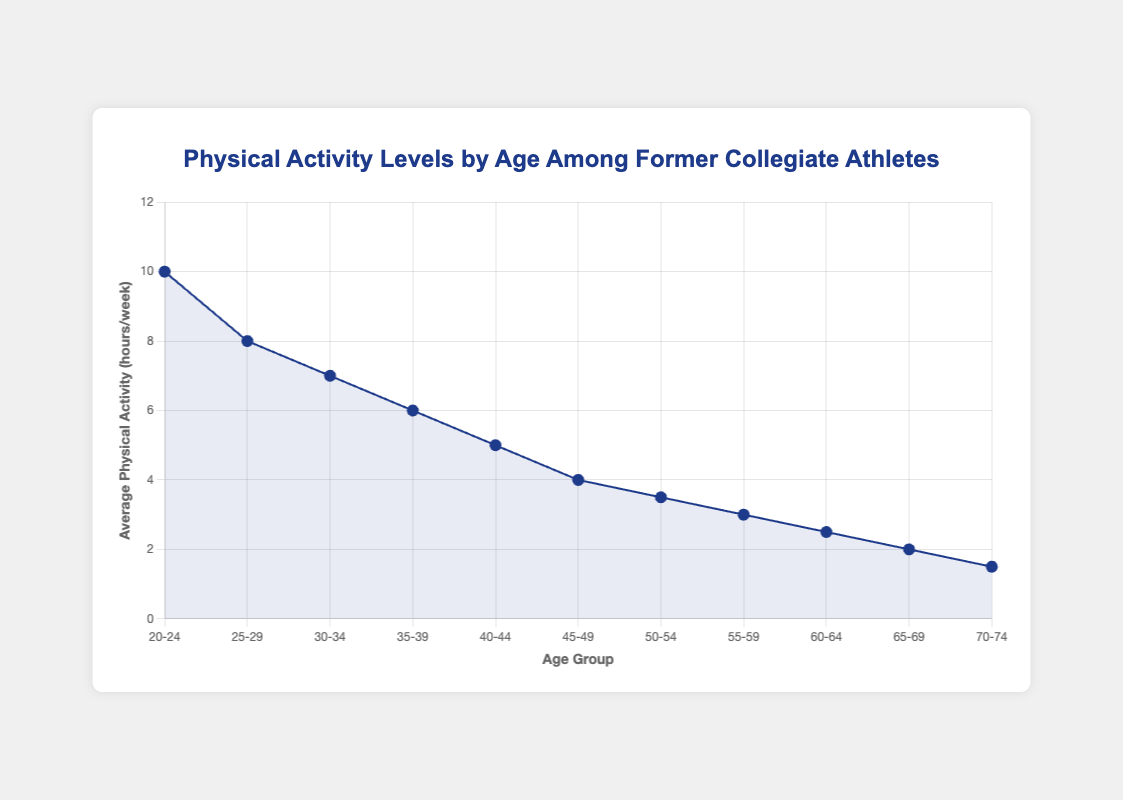What's the average number of physical activity hours per week for the 30-34 and 35-39 age groups combined? Add the average physical activity hours per week for the 30-34 (7 hours) and 35-39 (6 hours) age groups: 7 + 6 = 13. Then, divide by 2 to get the average: 13 / 2 = 6.5
Answer: 6.5 Which age group has the highest average physical activity hours per week? Looking at the figure, the age group with the highest point on the Y-axis is 20-24, which has 10 hours per week
Answer: 20-24 How does the decline in physical activity hours from the 20-24 age group to the 40-44 age group compare? The 20-24 age group has 10 hours per week and the 40-44 age group has 5 hours per week. The decline is: 10 - 5 = 5 hours
Answer: 5 hours Compare the difference in physical activity hours per week between the 25-29 and 50-54 age groups. The 25-29 age group has 8 hours per week, and the 50-54 age group has 3.5 hours per week. The difference is: 8 - 3.5 = 4.5 hours
Answer: 4.5 hours What's the overall trend in physical activity hours as age increases from 20-24 to 70-74? Observing the line plot, there is a consistent decrease in physical activity hours per week from the youngest group (20-24) to the oldest group (70-74)
Answer: Consistent decrease What is the sample size for the age group with the lowest physical activity hours per week? The age group with the lowest physical activity hours per week is 70-74, with 1.5 hours per week. The sample size for this group is 20
Answer: 20 How does the standard deviation change from the 20-24 to the 70-74 age group? The standard deviation decreases from 2.5 for the 20-24 age group to 1.4 for the 70-74 age group, indicating reduced variability in physical activity hours as age increases
Answer: Decrease Which age group has the smallest standard deviation in physical activity hours per week? Looking at the provided data, the age group with the smallest standard deviation (1.4) is 70-74
Answer: 70-74 How does the physical activity level of the 45-49 age group compare in terms of the average and standard deviation? The 45-49 age group has an average of 4 hours per week with a standard deviation of 2, indicating moderate variability around this average
Answer: 4 hours per week, standard deviation 2 